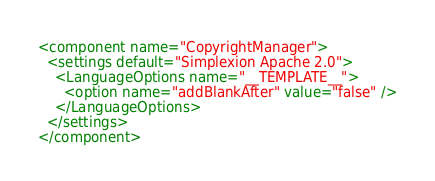Convert code to text. <code><loc_0><loc_0><loc_500><loc_500><_XML_><component name="CopyrightManager">
  <settings default="Simplexion Apache 2.0">
    <LanguageOptions name="__TEMPLATE__">
      <option name="addBlankAfter" value="false" />
    </LanguageOptions>
  </settings>
</component></code> 